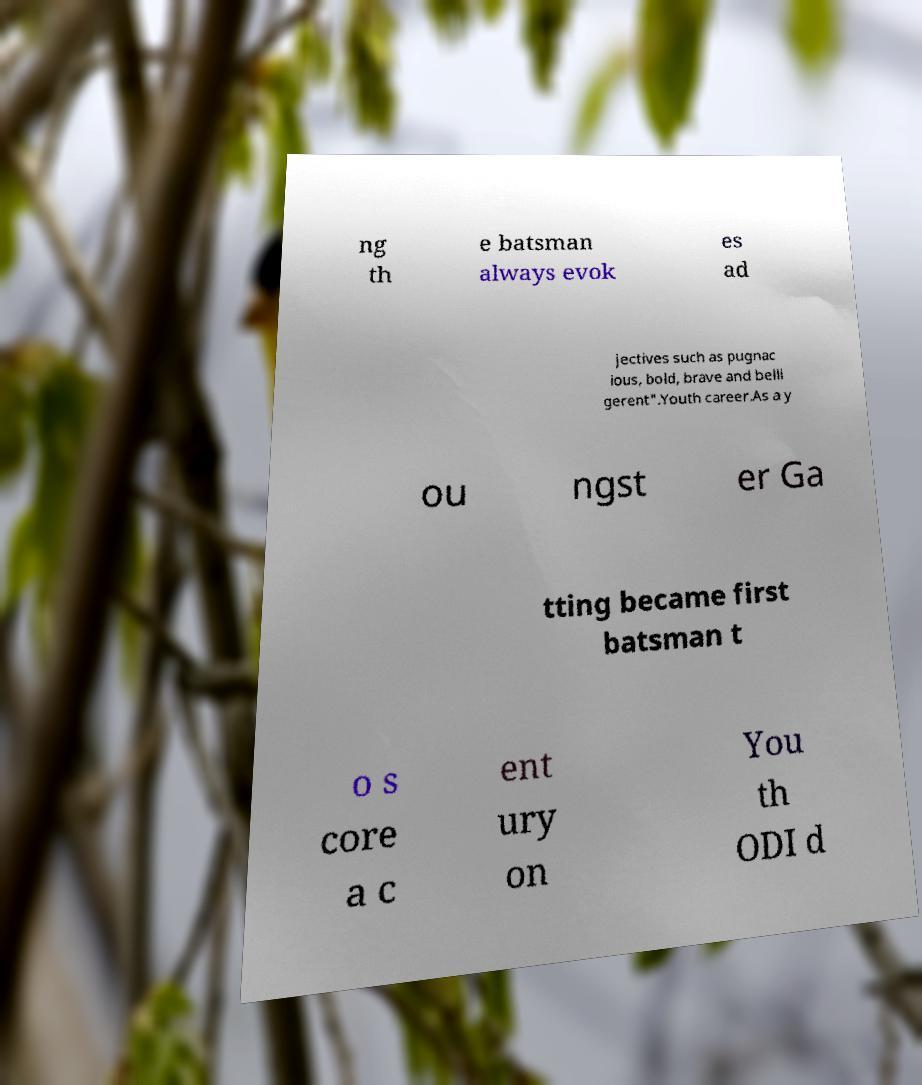Can you accurately transcribe the text from the provided image for me? ng th e batsman always evok es ad jectives such as pugnac ious, bold, brave and belli gerent".Youth career.As a y ou ngst er Ga tting became first batsman t o s core a c ent ury on You th ODI d 